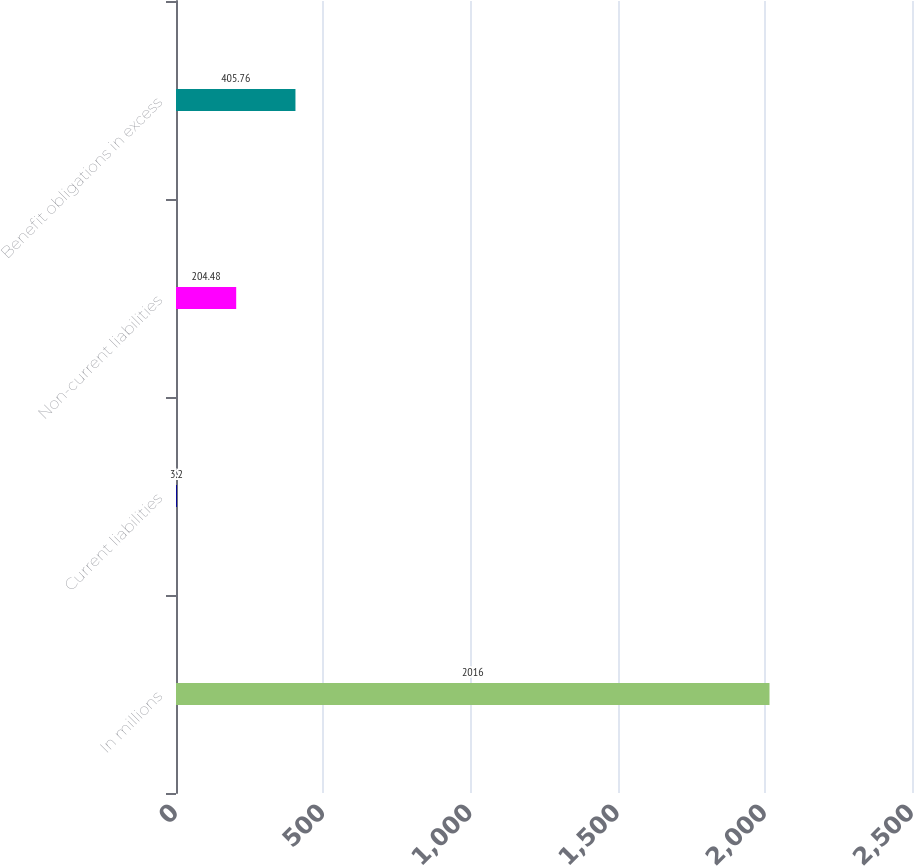<chart> <loc_0><loc_0><loc_500><loc_500><bar_chart><fcel>In millions<fcel>Current liabilities<fcel>Non-current liabilities<fcel>Benefit obligations in excess<nl><fcel>2016<fcel>3.2<fcel>204.48<fcel>405.76<nl></chart> 